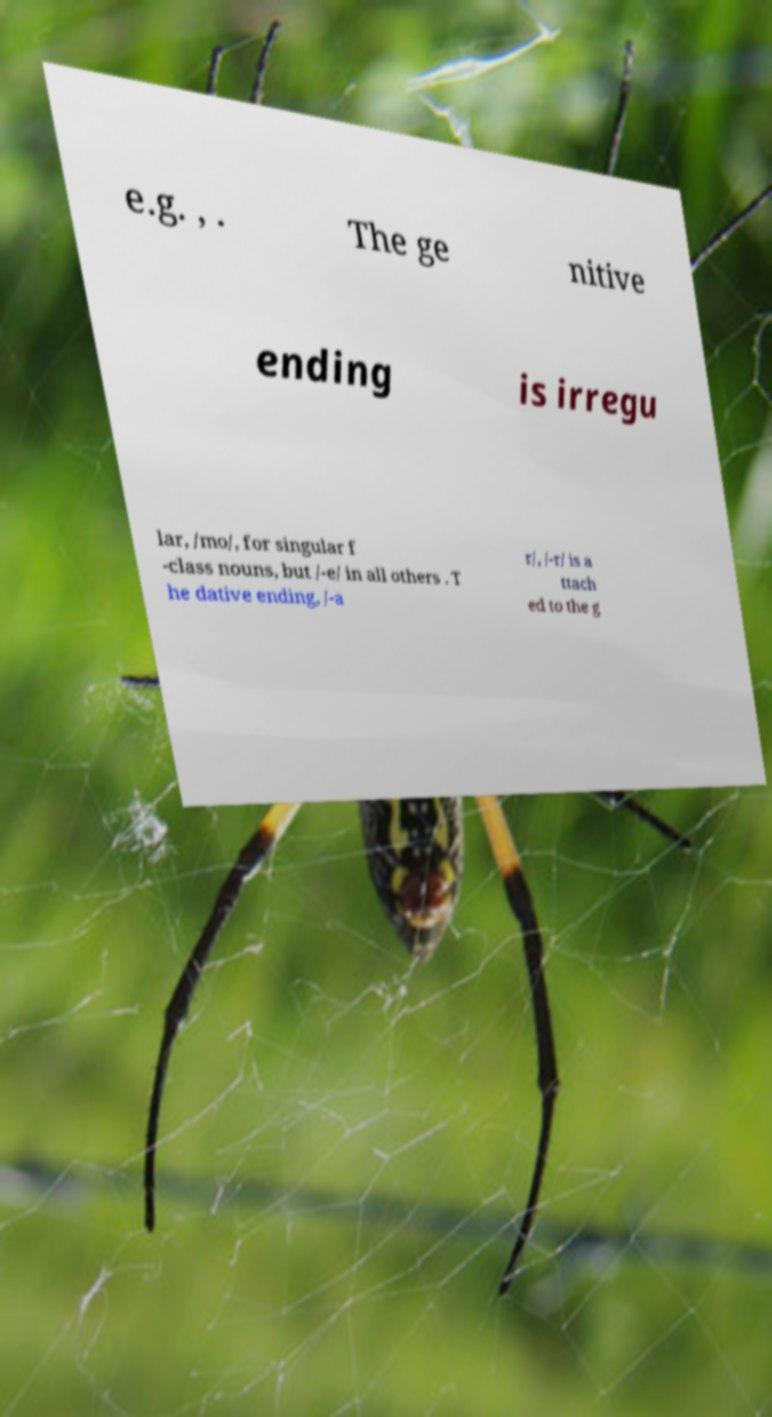Please read and relay the text visible in this image. What does it say? e.g. , . The ge nitive ending is irregu lar, /mo/, for singular f -class nouns, but /-e/ in all others . T he dative ending, /-a r/, /-r/ is a ttach ed to the g 